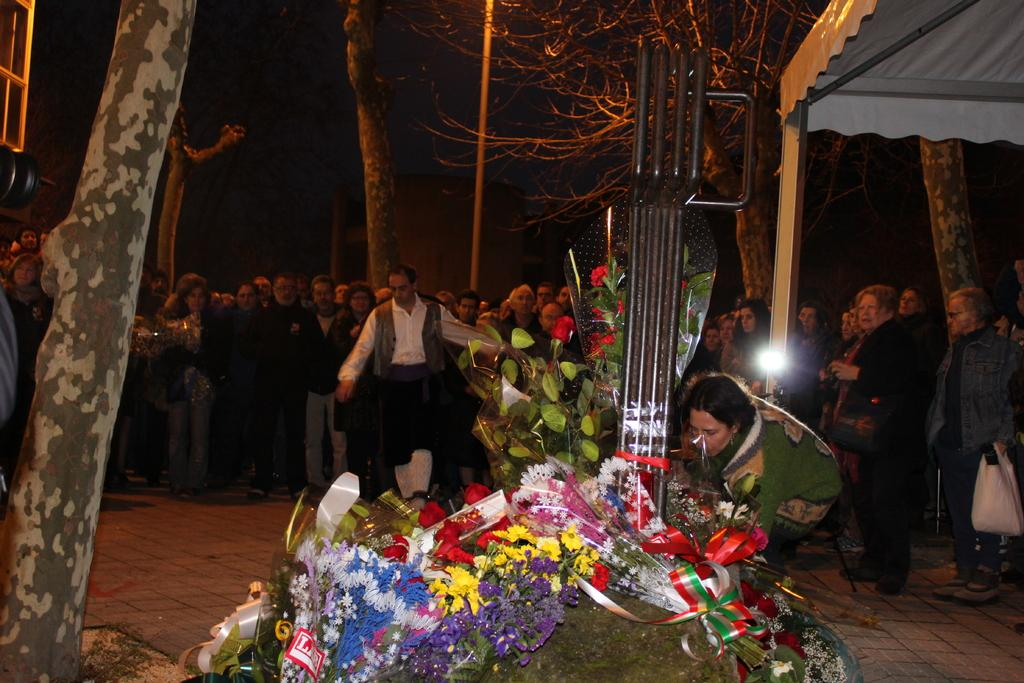What can be seen in the image involving people? There are people standing in the image. What is on the ground near the people? Flower bouquets are present on the ground. What type of surface is the ground made of? There is grass on the ground. What structures can be seen in the image? Iron poles are visible in the image. What type of shelter is present in the image? There is a tent in the image. What route are the people taking in the image? There is no indication of a specific route in the image; it only shows people standing with flower bouquets, grass, iron poles, and a tent. 